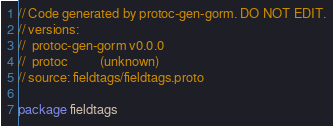<code> <loc_0><loc_0><loc_500><loc_500><_Go_>// Code generated by protoc-gen-gorm. DO NOT EDIT.
// versions:
// 	protoc-gen-gorm v0.0.0
// 	protoc          (unknown)
// source: fieldtags/fieldtags.proto

package fieldtags
</code> 